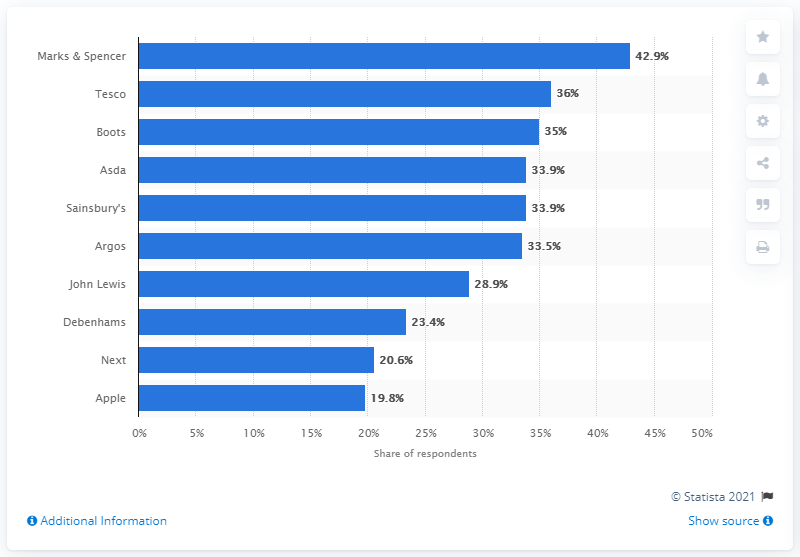Identify some key points in this picture. Boots was the second best customer experience brand in the UK in 2014. 